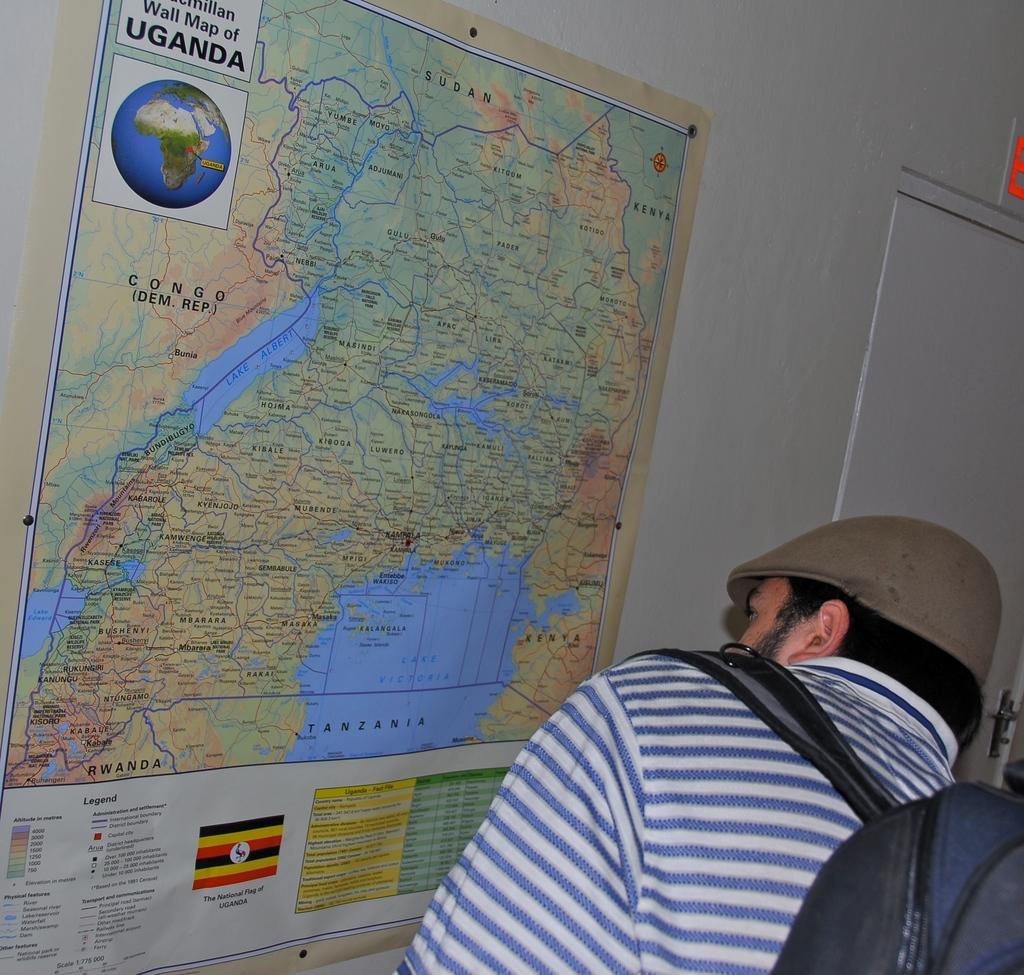Please provide a concise description of this image. In this image we can see a man. We can also see a map on a wall and a door. 